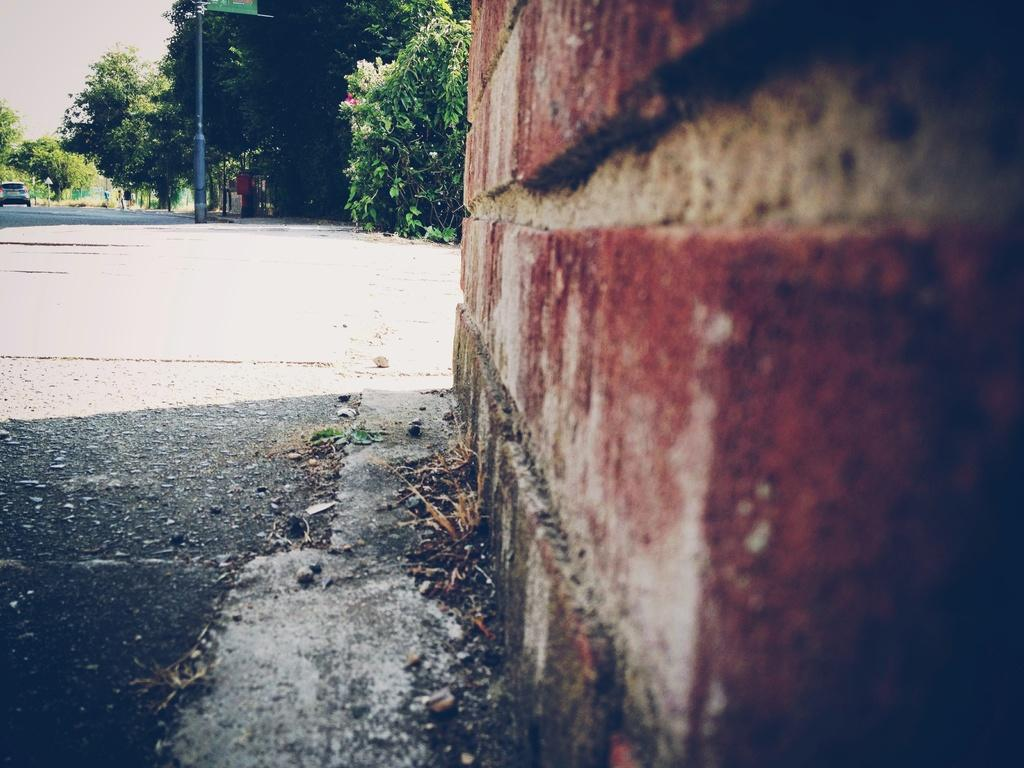What is located beside the road in the image? There is a building beside the road in the image. What is happening on the road? There are cars riding on the road. What type of vegetation is beside the road? There are trees beside the road. Can you tell me how many lamps are hanging from the trees beside the road? There are no lamps hanging from the trees beside the road in the image. Is there a maid working inside the building beside the road? There is no information about a maid working inside the building in the image. 